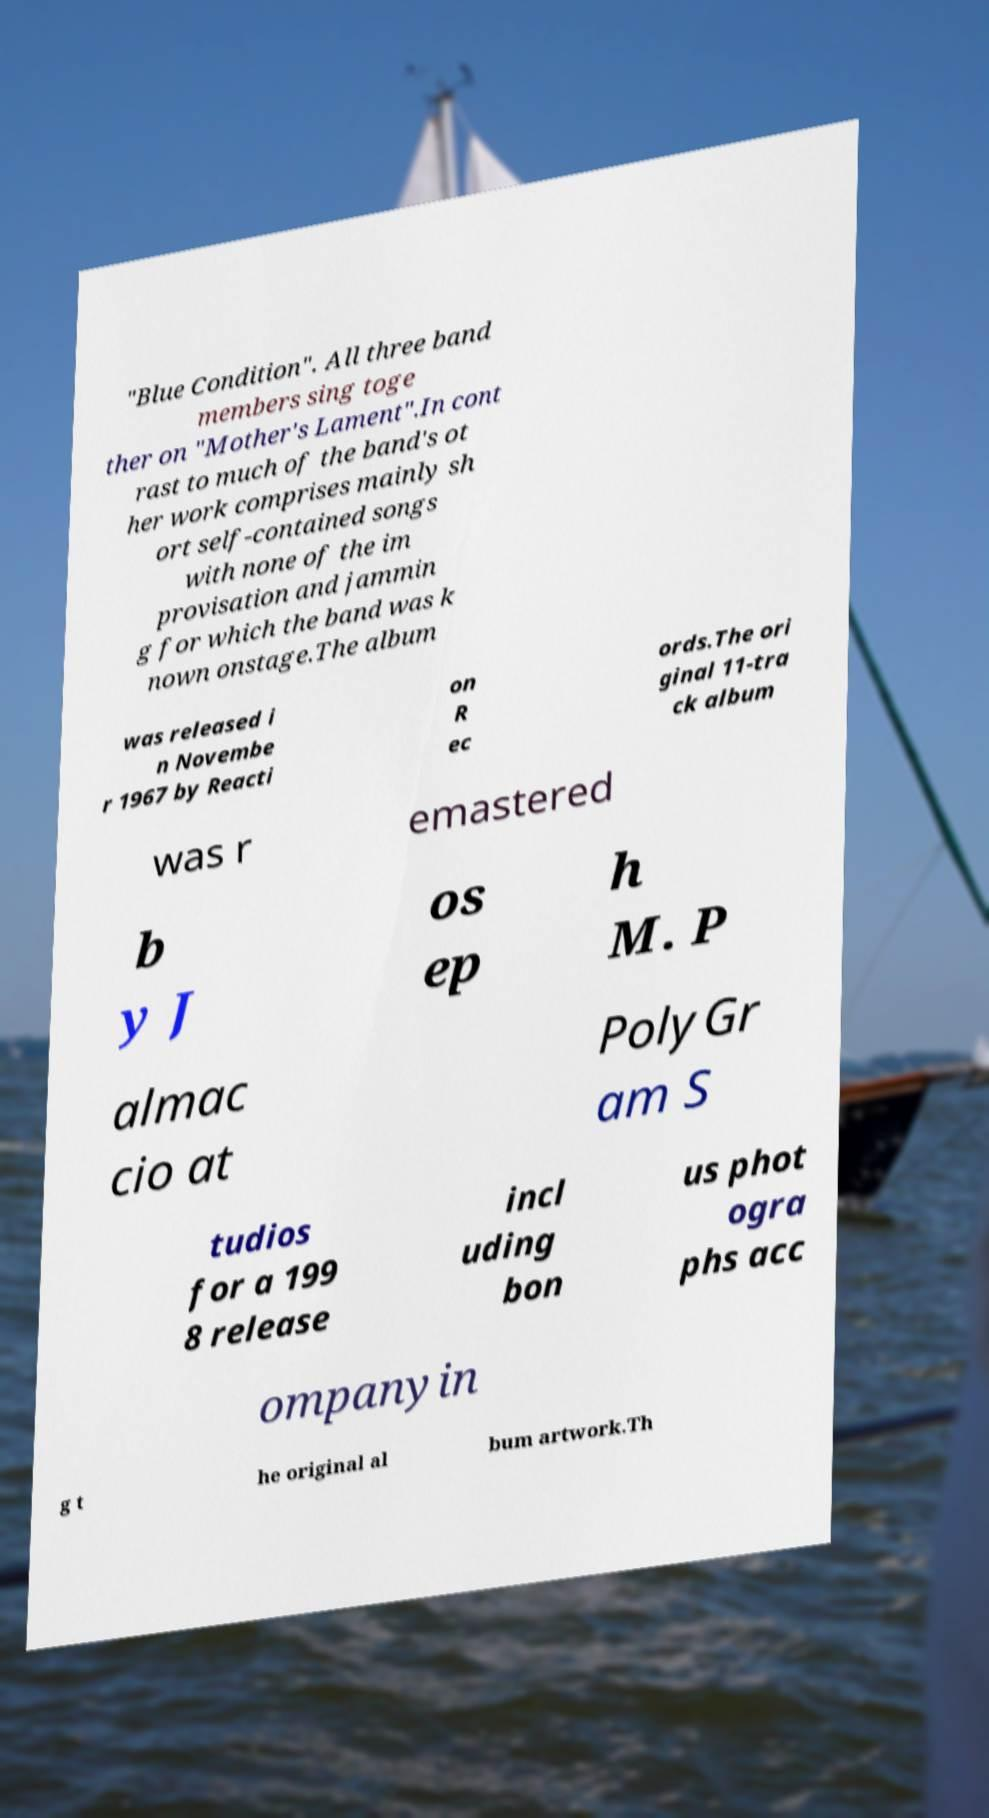Please read and relay the text visible in this image. What does it say? "Blue Condition". All three band members sing toge ther on "Mother's Lament".In cont rast to much of the band's ot her work comprises mainly sh ort self-contained songs with none of the im provisation and jammin g for which the band was k nown onstage.The album was released i n Novembe r 1967 by Reacti on R ec ords.The ori ginal 11-tra ck album was r emastered b y J os ep h M. P almac cio at PolyGr am S tudios for a 199 8 release incl uding bon us phot ogra phs acc ompanyin g t he original al bum artwork.Th 